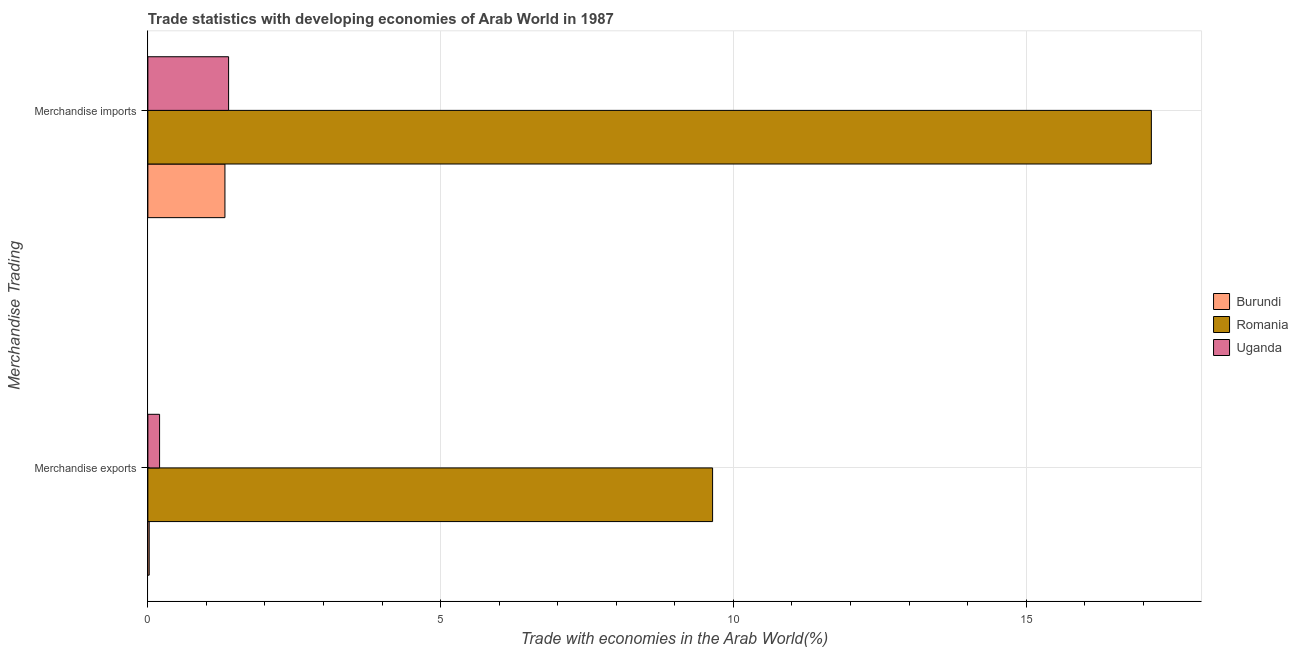Are the number of bars on each tick of the Y-axis equal?
Make the answer very short. Yes. What is the label of the 1st group of bars from the top?
Provide a short and direct response. Merchandise imports. What is the merchandise imports in Uganda?
Ensure brevity in your answer.  1.38. Across all countries, what is the maximum merchandise exports?
Provide a short and direct response. 9.64. Across all countries, what is the minimum merchandise exports?
Give a very brief answer. 0.02. In which country was the merchandise exports maximum?
Your answer should be compact. Romania. In which country was the merchandise exports minimum?
Your response must be concise. Burundi. What is the total merchandise imports in the graph?
Offer a very short reply. 19.83. What is the difference between the merchandise imports in Burundi and that in Uganda?
Keep it short and to the point. -0.06. What is the difference between the merchandise imports in Burundi and the merchandise exports in Romania?
Give a very brief answer. -8.33. What is the average merchandise exports per country?
Offer a terse response. 3.29. What is the difference between the merchandise exports and merchandise imports in Burundi?
Keep it short and to the point. -1.29. What is the ratio of the merchandise imports in Uganda to that in Romania?
Give a very brief answer. 0.08. Is the merchandise exports in Uganda less than that in Romania?
Your answer should be compact. Yes. In how many countries, is the merchandise imports greater than the average merchandise imports taken over all countries?
Make the answer very short. 1. What does the 3rd bar from the top in Merchandise imports represents?
Your answer should be compact. Burundi. What does the 3rd bar from the bottom in Merchandise imports represents?
Ensure brevity in your answer.  Uganda. How many bars are there?
Your response must be concise. 6. Are all the bars in the graph horizontal?
Keep it short and to the point. Yes. How many countries are there in the graph?
Provide a succinct answer. 3. Are the values on the major ticks of X-axis written in scientific E-notation?
Offer a very short reply. No. Does the graph contain any zero values?
Provide a short and direct response. No. Where does the legend appear in the graph?
Make the answer very short. Center right. How many legend labels are there?
Your answer should be very brief. 3. What is the title of the graph?
Provide a succinct answer. Trade statistics with developing economies of Arab World in 1987. What is the label or title of the X-axis?
Your response must be concise. Trade with economies in the Arab World(%). What is the label or title of the Y-axis?
Offer a terse response. Merchandise Trading. What is the Trade with economies in the Arab World(%) of Burundi in Merchandise exports?
Your answer should be compact. 0.02. What is the Trade with economies in the Arab World(%) in Romania in Merchandise exports?
Your answer should be compact. 9.64. What is the Trade with economies in the Arab World(%) of Uganda in Merchandise exports?
Your response must be concise. 0.2. What is the Trade with economies in the Arab World(%) of Burundi in Merchandise imports?
Offer a terse response. 1.32. What is the Trade with economies in the Arab World(%) in Romania in Merchandise imports?
Your answer should be compact. 17.14. What is the Trade with economies in the Arab World(%) of Uganda in Merchandise imports?
Your response must be concise. 1.38. Across all Merchandise Trading, what is the maximum Trade with economies in the Arab World(%) of Burundi?
Give a very brief answer. 1.32. Across all Merchandise Trading, what is the maximum Trade with economies in the Arab World(%) in Romania?
Your answer should be compact. 17.14. Across all Merchandise Trading, what is the maximum Trade with economies in the Arab World(%) in Uganda?
Give a very brief answer. 1.38. Across all Merchandise Trading, what is the minimum Trade with economies in the Arab World(%) in Burundi?
Make the answer very short. 0.02. Across all Merchandise Trading, what is the minimum Trade with economies in the Arab World(%) in Romania?
Make the answer very short. 9.64. Across all Merchandise Trading, what is the minimum Trade with economies in the Arab World(%) in Uganda?
Keep it short and to the point. 0.2. What is the total Trade with economies in the Arab World(%) of Burundi in the graph?
Your answer should be very brief. 1.34. What is the total Trade with economies in the Arab World(%) of Romania in the graph?
Ensure brevity in your answer.  26.78. What is the total Trade with economies in the Arab World(%) of Uganda in the graph?
Offer a terse response. 1.58. What is the difference between the Trade with economies in the Arab World(%) of Burundi in Merchandise exports and that in Merchandise imports?
Make the answer very short. -1.29. What is the difference between the Trade with economies in the Arab World(%) in Romania in Merchandise exports and that in Merchandise imports?
Your answer should be compact. -7.49. What is the difference between the Trade with economies in the Arab World(%) in Uganda in Merchandise exports and that in Merchandise imports?
Make the answer very short. -1.18. What is the difference between the Trade with economies in the Arab World(%) of Burundi in Merchandise exports and the Trade with economies in the Arab World(%) of Romania in Merchandise imports?
Make the answer very short. -17.11. What is the difference between the Trade with economies in the Arab World(%) in Burundi in Merchandise exports and the Trade with economies in the Arab World(%) in Uganda in Merchandise imports?
Ensure brevity in your answer.  -1.36. What is the difference between the Trade with economies in the Arab World(%) of Romania in Merchandise exports and the Trade with economies in the Arab World(%) of Uganda in Merchandise imports?
Provide a short and direct response. 8.27. What is the average Trade with economies in the Arab World(%) of Burundi per Merchandise Trading?
Make the answer very short. 0.67. What is the average Trade with economies in the Arab World(%) in Romania per Merchandise Trading?
Ensure brevity in your answer.  13.39. What is the average Trade with economies in the Arab World(%) of Uganda per Merchandise Trading?
Keep it short and to the point. 0.79. What is the difference between the Trade with economies in the Arab World(%) in Burundi and Trade with economies in the Arab World(%) in Romania in Merchandise exports?
Your answer should be very brief. -9.62. What is the difference between the Trade with economies in the Arab World(%) in Burundi and Trade with economies in the Arab World(%) in Uganda in Merchandise exports?
Provide a succinct answer. -0.18. What is the difference between the Trade with economies in the Arab World(%) in Romania and Trade with economies in the Arab World(%) in Uganda in Merchandise exports?
Provide a short and direct response. 9.44. What is the difference between the Trade with economies in the Arab World(%) in Burundi and Trade with economies in the Arab World(%) in Romania in Merchandise imports?
Your answer should be very brief. -15.82. What is the difference between the Trade with economies in the Arab World(%) of Burundi and Trade with economies in the Arab World(%) of Uganda in Merchandise imports?
Provide a succinct answer. -0.06. What is the difference between the Trade with economies in the Arab World(%) in Romania and Trade with economies in the Arab World(%) in Uganda in Merchandise imports?
Offer a very short reply. 15.76. What is the ratio of the Trade with economies in the Arab World(%) in Burundi in Merchandise exports to that in Merchandise imports?
Offer a very short reply. 0.02. What is the ratio of the Trade with economies in the Arab World(%) in Romania in Merchandise exports to that in Merchandise imports?
Keep it short and to the point. 0.56. What is the ratio of the Trade with economies in the Arab World(%) of Uganda in Merchandise exports to that in Merchandise imports?
Provide a short and direct response. 0.14. What is the difference between the highest and the second highest Trade with economies in the Arab World(%) in Burundi?
Your answer should be compact. 1.29. What is the difference between the highest and the second highest Trade with economies in the Arab World(%) of Romania?
Provide a short and direct response. 7.49. What is the difference between the highest and the second highest Trade with economies in the Arab World(%) of Uganda?
Your response must be concise. 1.18. What is the difference between the highest and the lowest Trade with economies in the Arab World(%) in Burundi?
Your answer should be very brief. 1.29. What is the difference between the highest and the lowest Trade with economies in the Arab World(%) in Romania?
Make the answer very short. 7.49. What is the difference between the highest and the lowest Trade with economies in the Arab World(%) in Uganda?
Keep it short and to the point. 1.18. 